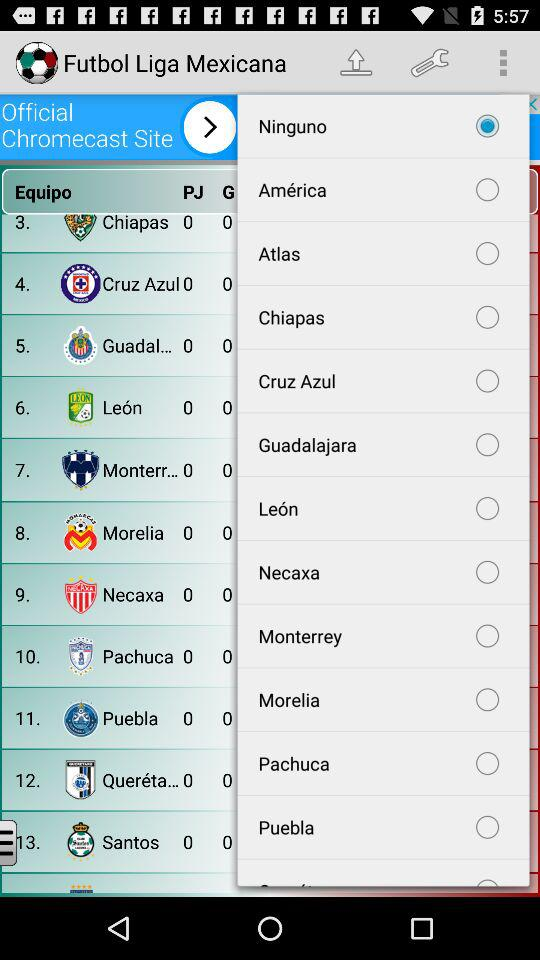Which option is selected? The selected option is "Ninguno". 